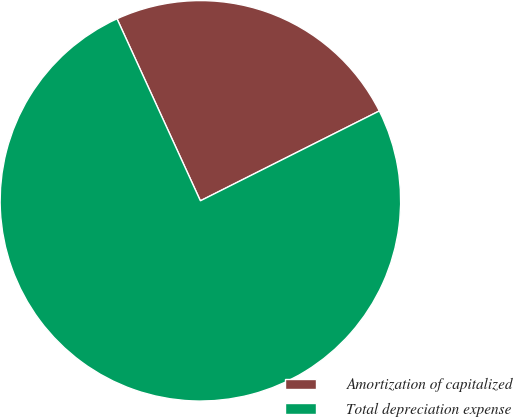Convert chart. <chart><loc_0><loc_0><loc_500><loc_500><pie_chart><fcel>Amortization of capitalized<fcel>Total depreciation expense<nl><fcel>24.43%<fcel>75.57%<nl></chart> 